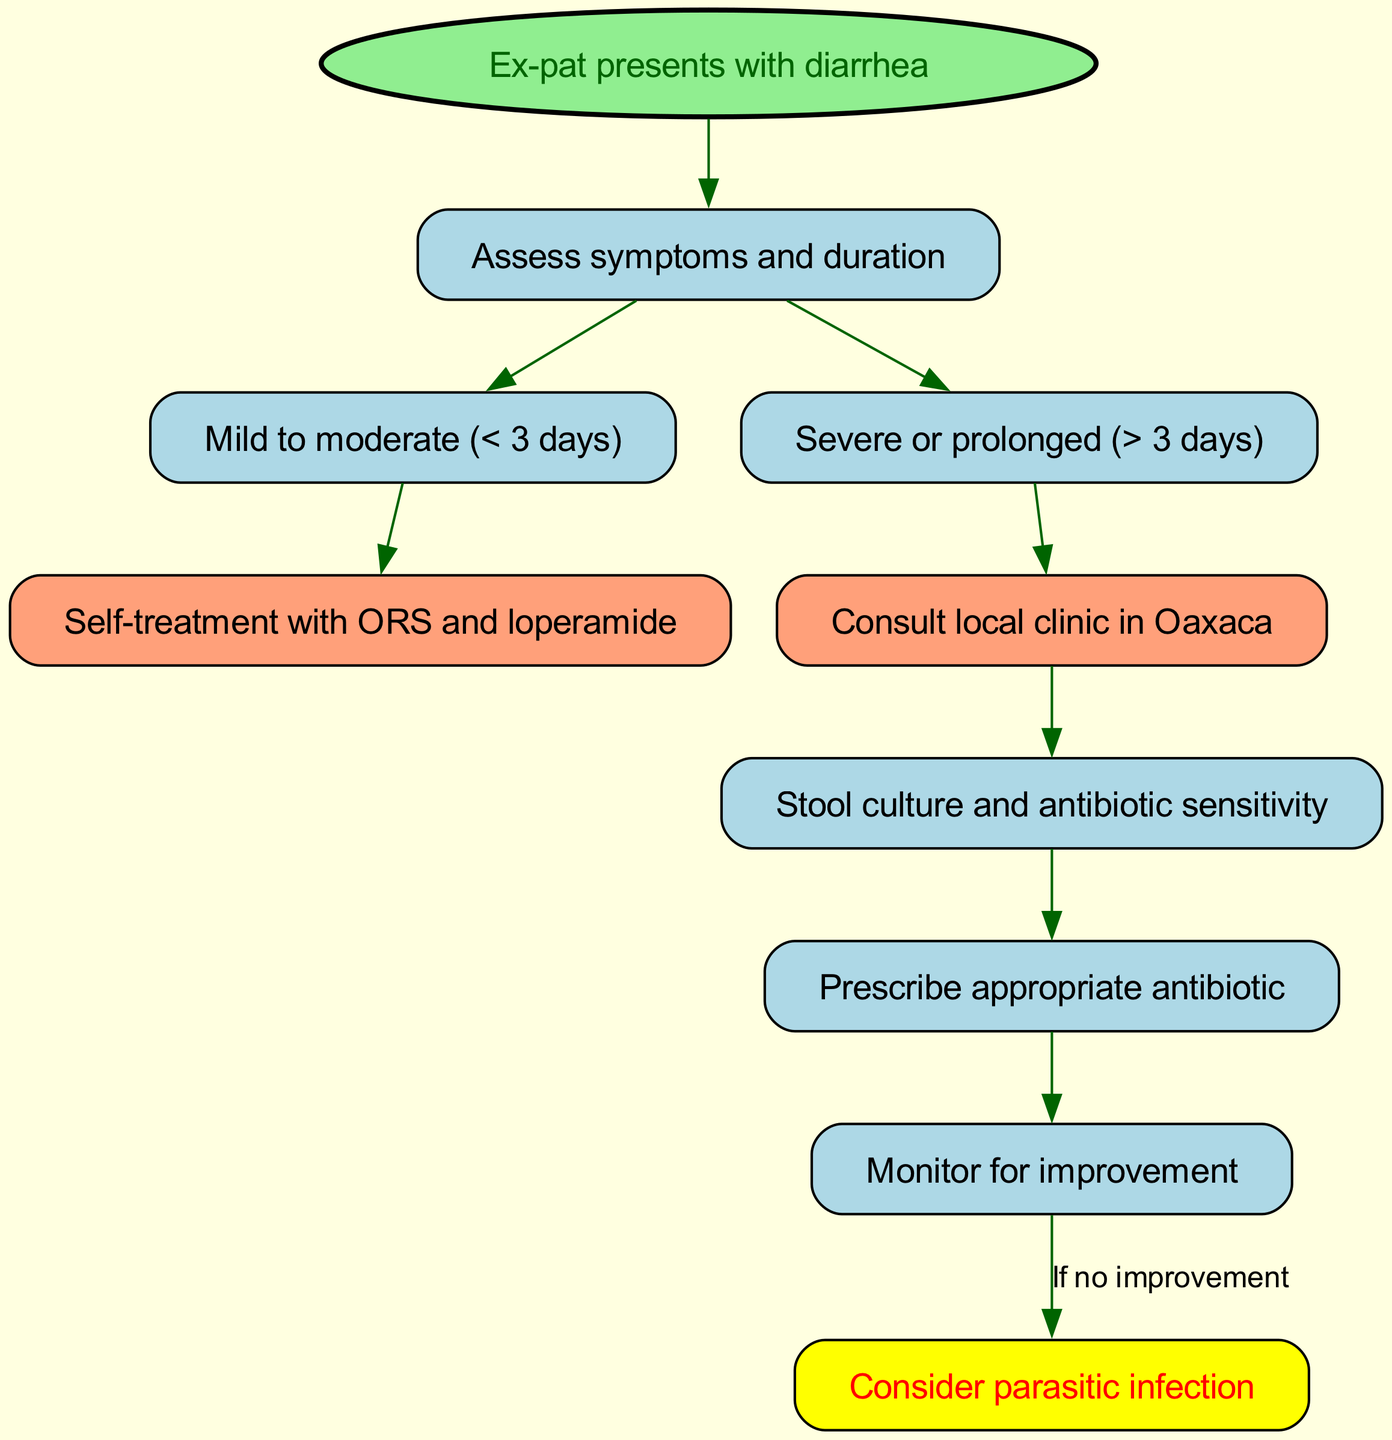What is the first step when an ex-pat presents with diarrhea? The first step in the clinical pathway is for the ex-pat to "Assess symptoms and duration," which is indicated by the edge connecting nodes 1 and 2.
Answer: Assess symptoms and duration How many nodes are there in the diagram? The diagram contains a total of 10 nodes, which can be counted from the data provided.
Answer: 10 What action occurs after assessing symptoms and duration if the diarrhea is mild to moderate? If the diarrhea is mild to moderate (less than 3 days), the next action is "Self-treatment with ORS and loperamide," indicated by the edge from node 3 to node 5.
Answer: Self-treatment with ORS and loperamide What should be done if diarrhea is severe or prolonged? In the case of severe or prolonged diarrhea (more than 3 days), the next step is to "Consult local clinic in Oaxaca," as shown by the edge from node 4 to node 6.
Answer: Consult local clinic in Oaxaca What happens after a stool culture and antibiotic sensitivity test? After conducting a stool culture and antibiotic sensitivity test, the next action is to "Prescribe appropriate antibiotic," which follows from node 7 to node 8.
Answer: Prescribe appropriate antibiotic What is the consequence if there is no improvement after monitoring? If there is no improvement after monitoring, the next step is to "Consider parasitic infection," as indicated by the edge from node 9 to node 10.
Answer: Consider parasitic infection How many edges connect the nodes in this diagram? The diagram has 9 edges, which can be counted from the data by examining the connections (from one node to another).
Answer: 9 What color represents self-treatment nodes in the pathway? The nodes representing self-treatment, specifically node 5 and node 6, are both filled with a "lightsalmon" color, as stated in the customization of nodes.
Answer: lightsalmon What is the relationship between nodes 2 and 3? There is a direct relationship where node 2 leads to node 3, indicated by the edge connecting these two nodes, which specifies that after assessing symptoms, we categorize it as mild to moderate.
Answer: Assess symptoms and duration leads to mild to moderate What does the diagram suggest should be monitored after prescribing antibiotics? After prescribing antibiotics, the next suggested action is to "Monitor for improvement," which is indicated by the flow from node 8 to node 9.
Answer: Monitor for improvement 